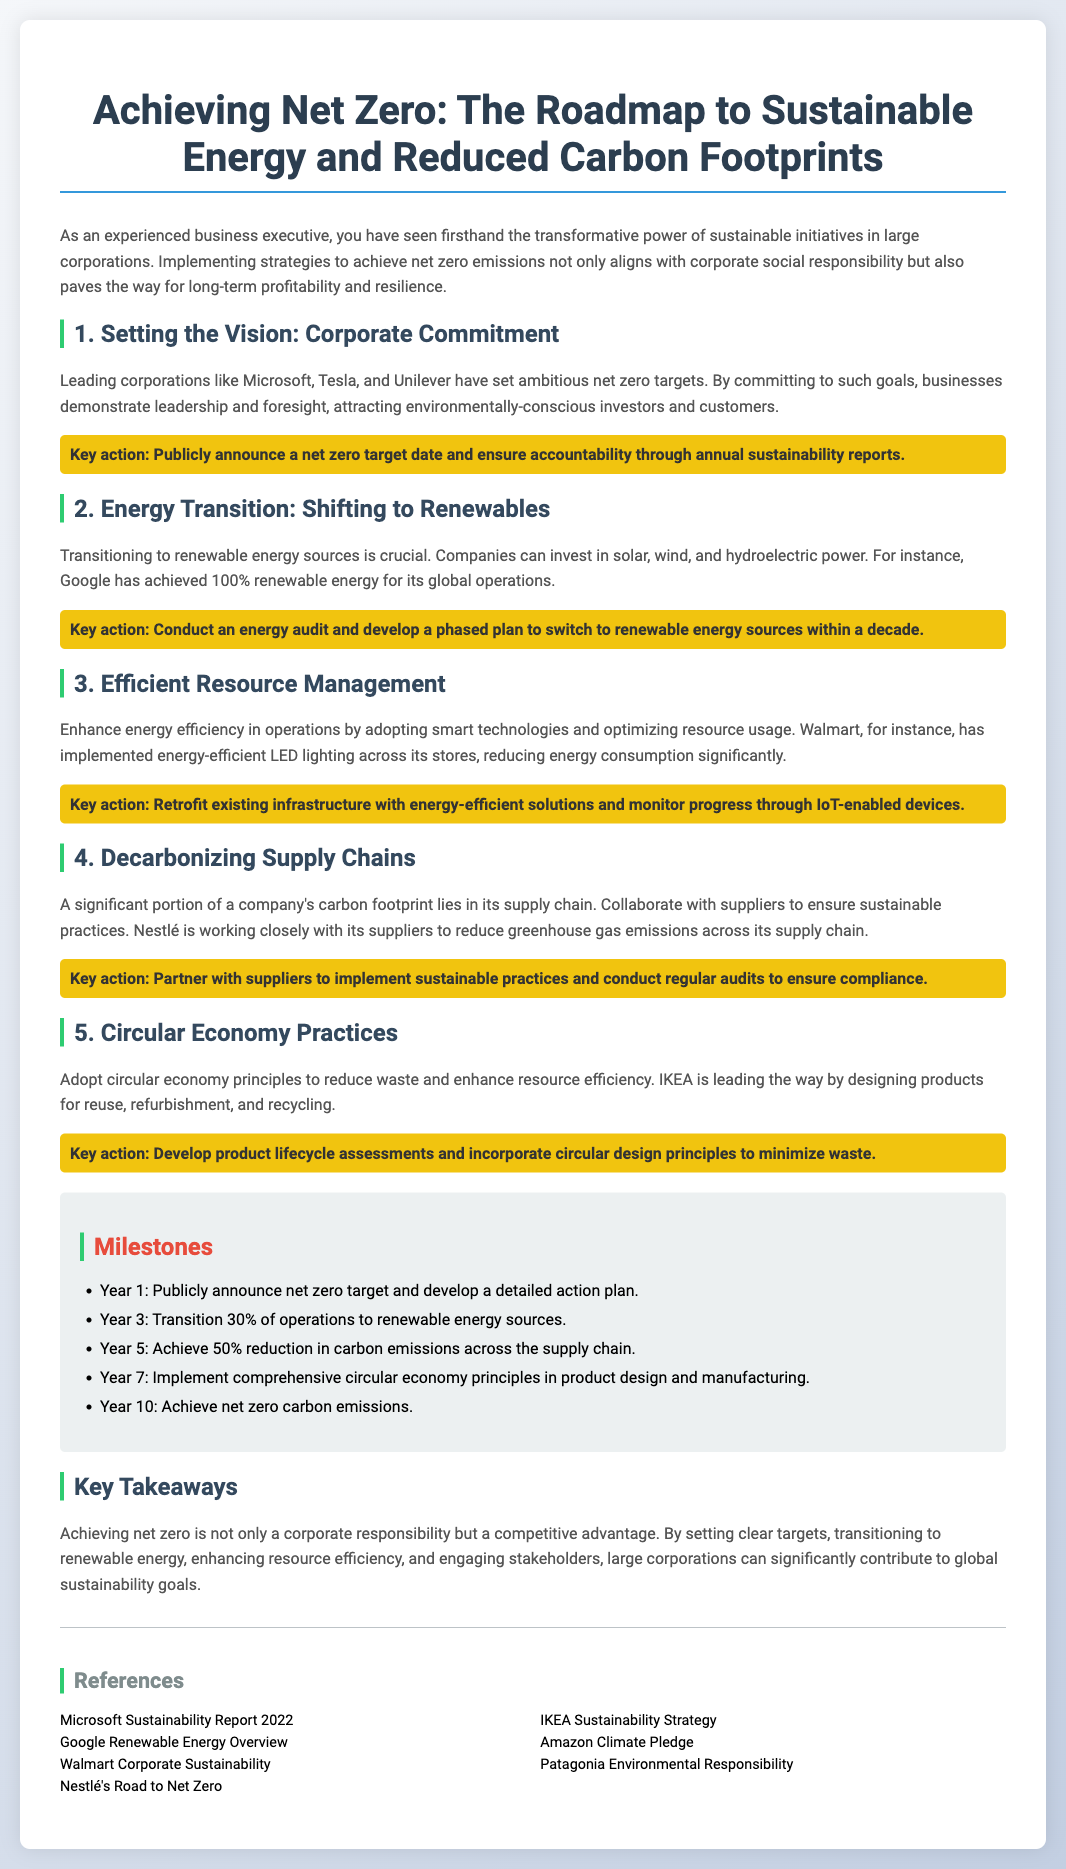what is the main title of the poster? The main title is stated at the top of the document, summarizing the focus on sustainable energy and carbon footprints.
Answer: Achieving Net Zero: The Roadmap to Sustainable Energy and Reduced Carbon Footprints which company achieved 100% renewable energy for its global operations? The document mentions a specific company that has achieved this milestone in renewable energy usage.
Answer: Google what is the key action related to energy transition? Each section includes a key action that companies can undertake to help with the respective focus area.
Answer: Conduct an energy audit and develop a phased plan to switch to renewable energy sources within a decade in what year does the poster suggest achieving net zero carbon emissions? The milestones section outlines the timeline for achieving specific sustainability goals, including the target for net zero emissions.
Answer: Year 10 which company's sustainability strategy is focused on reducing waste? The content provides examples of companies that follow circular economy principles to minimize waste.
Answer: IKEA what is the percentage reduction in carbon emissions aimed for by year 5? This figure is part of the milestones that outline specific performance goals for sustainability.
Answer: 50% what action is recommended for enhancing resource management? The document provides an actionable step for improving resource efficiency, including technology integration.
Answer: Retrofit existing infrastructure with energy-efficient solutions and monitor progress through IoT-enabled devices how many years is the roadmap set for to achieve net zero? The milestones section indicates a timeline for the roadmap designed to reach net zero emissions.
Answer: 10 years 